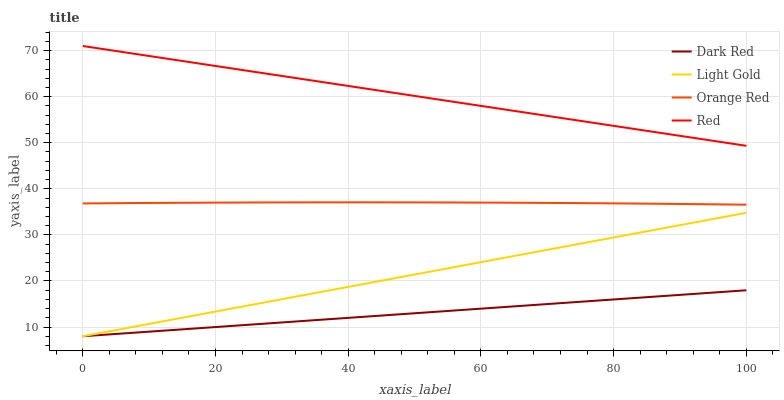Does Light Gold have the minimum area under the curve?
Answer yes or no. No. Does Light Gold have the maximum area under the curve?
Answer yes or no. No. Is Light Gold the smoothest?
Answer yes or no. No. Is Light Gold the roughest?
Answer yes or no. No. Does Orange Red have the lowest value?
Answer yes or no. No. Does Light Gold have the highest value?
Answer yes or no. No. Is Light Gold less than Orange Red?
Answer yes or no. Yes. Is Red greater than Orange Red?
Answer yes or no. Yes. Does Light Gold intersect Orange Red?
Answer yes or no. No. 